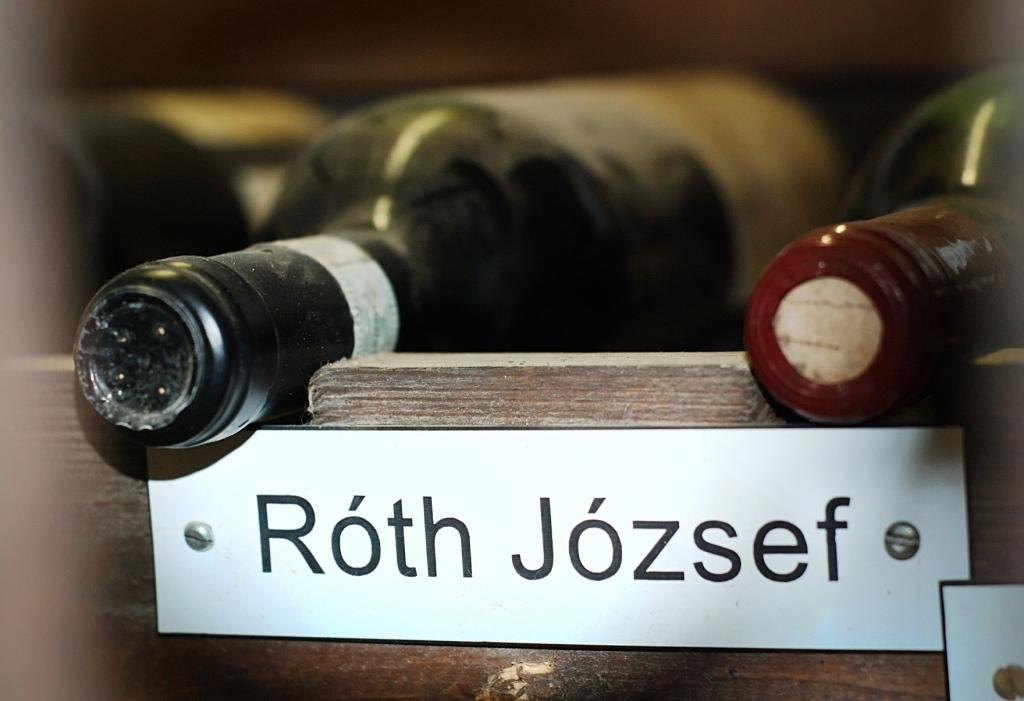<image>
Provide a brief description of the given image. A wine label with Roth Jozsef written on it. 